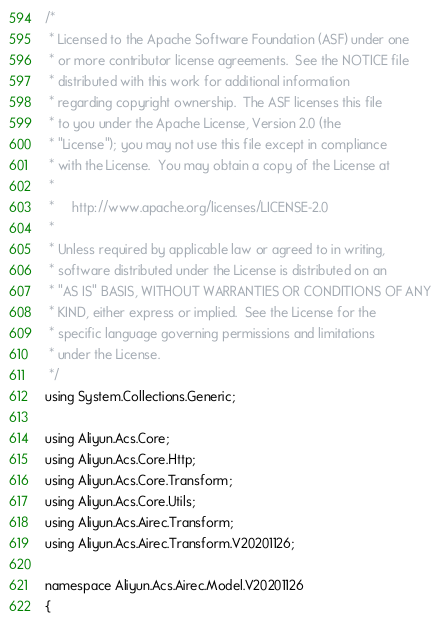<code> <loc_0><loc_0><loc_500><loc_500><_C#_>/*
 * Licensed to the Apache Software Foundation (ASF) under one
 * or more contributor license agreements.  See the NOTICE file
 * distributed with this work for additional information
 * regarding copyright ownership.  The ASF licenses this file
 * to you under the Apache License, Version 2.0 (the
 * "License"); you may not use this file except in compliance
 * with the License.  You may obtain a copy of the License at
 *
 *     http://www.apache.org/licenses/LICENSE-2.0
 *
 * Unless required by applicable law or agreed to in writing,
 * software distributed under the License is distributed on an
 * "AS IS" BASIS, WITHOUT WARRANTIES OR CONDITIONS OF ANY
 * KIND, either express or implied.  See the License for the
 * specific language governing permissions and limitations
 * under the License.
 */
using System.Collections.Generic;

using Aliyun.Acs.Core;
using Aliyun.Acs.Core.Http;
using Aliyun.Acs.Core.Transform;
using Aliyun.Acs.Core.Utils;
using Aliyun.Acs.Airec.Transform;
using Aliyun.Acs.Airec.Transform.V20201126;

namespace Aliyun.Acs.Airec.Model.V20201126
{</code> 